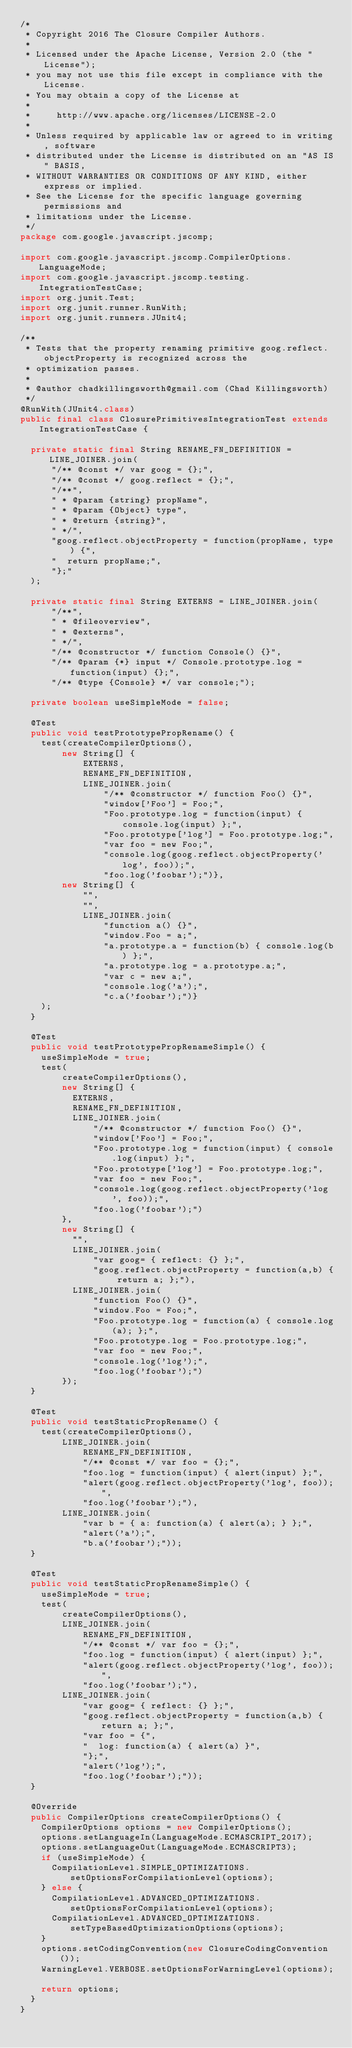<code> <loc_0><loc_0><loc_500><loc_500><_Java_>/*
 * Copyright 2016 The Closure Compiler Authors.
 *
 * Licensed under the Apache License, Version 2.0 (the "License");
 * you may not use this file except in compliance with the License.
 * You may obtain a copy of the License at
 *
 *     http://www.apache.org/licenses/LICENSE-2.0
 *
 * Unless required by applicable law or agreed to in writing, software
 * distributed under the License is distributed on an "AS IS" BASIS,
 * WITHOUT WARRANTIES OR CONDITIONS OF ANY KIND, either express or implied.
 * See the License for the specific language governing permissions and
 * limitations under the License.
 */
package com.google.javascript.jscomp;

import com.google.javascript.jscomp.CompilerOptions.LanguageMode;
import com.google.javascript.jscomp.testing.IntegrationTestCase;
import org.junit.Test;
import org.junit.runner.RunWith;
import org.junit.runners.JUnit4;

/**
 * Tests that the property renaming primitive goog.reflect.objectProperty is recognized across the
 * optimization passes.
 *
 * @author chadkillingsworth@gmail.com (Chad Killingsworth)
 */
@RunWith(JUnit4.class)
public final class ClosurePrimitivesIntegrationTest extends IntegrationTestCase {

  private static final String RENAME_FN_DEFINITION = LINE_JOINER.join(
      "/** @const */ var goog = {};",
      "/** @const */ goog.reflect = {};",
      "/**",
      " * @param {string} propName",
      " * @param {Object} type",
      " * @return {string}",
      " */",
      "goog.reflect.objectProperty = function(propName, type) {",
      "  return propName;",
      "};"
  );

  private static final String EXTERNS = LINE_JOINER.join(
      "/**",
      " * @fileoverview",
      " * @externs",
      " */",
      "/** @constructor */ function Console() {}",
      "/** @param {*} input */ Console.prototype.log = function(input) {};",
      "/** @type {Console} */ var console;");

  private boolean useSimpleMode = false;

  @Test
  public void testPrototypePropRename() {
    test(createCompilerOptions(),
        new String[] {
            EXTERNS,
            RENAME_FN_DEFINITION,
            LINE_JOINER.join(
                "/** @constructor */ function Foo() {}",
                "window['Foo'] = Foo;",
                "Foo.prototype.log = function(input) { console.log(input) };",
                "Foo.prototype['log'] = Foo.prototype.log;",
                "var foo = new Foo;",
                "console.log(goog.reflect.objectProperty('log', foo));",
                "foo.log('foobar');")},
        new String[] {
            "",
            "",
            LINE_JOINER.join(
                "function a() {}",
                "window.Foo = a;",
                "a.prototype.a = function(b) { console.log(b) };",
                "a.prototype.log = a.prototype.a;",
                "var c = new a;",
                "console.log('a');",
                "c.a('foobar');")}
    );
  }

  @Test
  public void testPrototypePropRenameSimple() {
    useSimpleMode = true;
    test(
        createCompilerOptions(),
        new String[] {
          EXTERNS,
          RENAME_FN_DEFINITION,
          LINE_JOINER.join(
              "/** @constructor */ function Foo() {}",
              "window['Foo'] = Foo;",
              "Foo.prototype.log = function(input) { console.log(input) };",
              "Foo.prototype['log'] = Foo.prototype.log;",
              "var foo = new Foo;",
              "console.log(goog.reflect.objectProperty('log', foo));",
              "foo.log('foobar');")
        },
        new String[] {
          "",
          LINE_JOINER.join(
              "var goog= { reflect: {} };",
              "goog.reflect.objectProperty = function(a,b) { return a; };"),
          LINE_JOINER.join(
              "function Foo() {}",
              "window.Foo = Foo;",
              "Foo.prototype.log = function(a) { console.log(a); };",
              "Foo.prototype.log = Foo.prototype.log;",
              "var foo = new Foo;",
              "console.log('log');",
              "foo.log('foobar');")
        });
  }

  @Test
  public void testStaticPropRename() {
    test(createCompilerOptions(),
        LINE_JOINER.join(
            RENAME_FN_DEFINITION,
            "/** @const */ var foo = {};",
            "foo.log = function(input) { alert(input) };",
            "alert(goog.reflect.objectProperty('log', foo));",
            "foo.log('foobar');"),
        LINE_JOINER.join(
            "var b = { a: function(a) { alert(a); } };",
            "alert('a');",
            "b.a('foobar');"));
  }

  @Test
  public void testStaticPropRenameSimple() {
    useSimpleMode = true;
    test(
        createCompilerOptions(),
        LINE_JOINER.join(
            RENAME_FN_DEFINITION,
            "/** @const */ var foo = {};",
            "foo.log = function(input) { alert(input) };",
            "alert(goog.reflect.objectProperty('log', foo));",
            "foo.log('foobar');"),
        LINE_JOINER.join(
            "var goog= { reflect: {} };",
            "goog.reflect.objectProperty = function(a,b) { return a; };",
            "var foo = {",
            "  log: function(a) { alert(a) }",
            "};",
            "alert('log');",
            "foo.log('foobar');"));
  }

  @Override
  public CompilerOptions createCompilerOptions() {
    CompilerOptions options = new CompilerOptions();
    options.setLanguageIn(LanguageMode.ECMASCRIPT_2017);
    options.setLanguageOut(LanguageMode.ECMASCRIPT3);
    if (useSimpleMode) {
      CompilationLevel.SIMPLE_OPTIMIZATIONS.setOptionsForCompilationLevel(options);
    } else {
      CompilationLevel.ADVANCED_OPTIMIZATIONS.setOptionsForCompilationLevel(options);
      CompilationLevel.ADVANCED_OPTIMIZATIONS.setTypeBasedOptimizationOptions(options);
    }
    options.setCodingConvention(new ClosureCodingConvention());
    WarningLevel.VERBOSE.setOptionsForWarningLevel(options);

    return options;
  }
}
</code> 